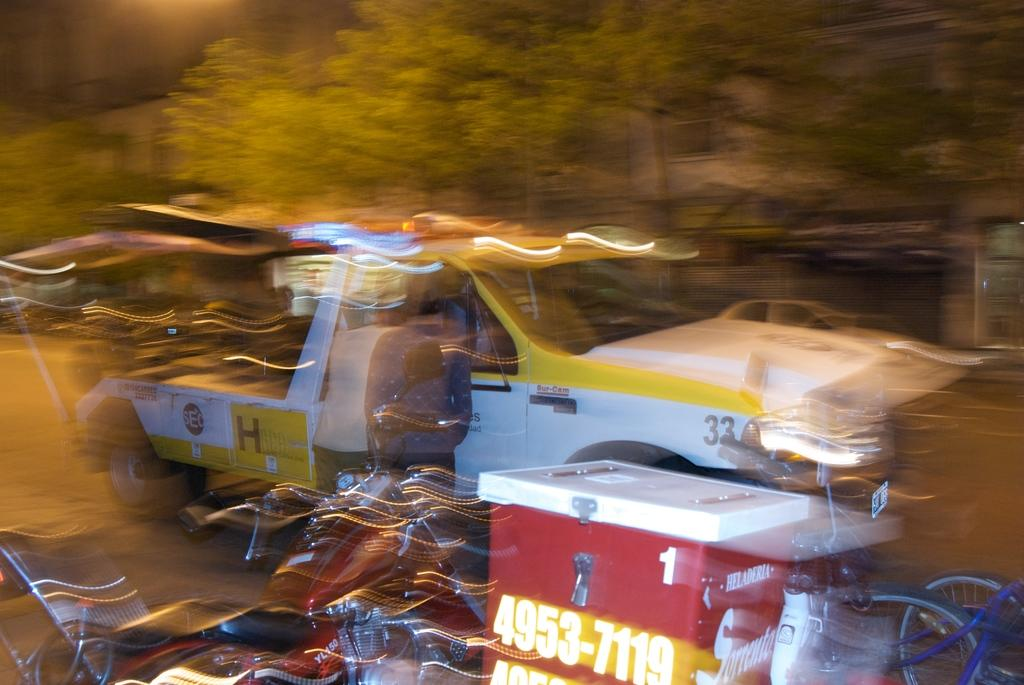What is happening on the road in the image? There are vehicles on the road in the image. What type of natural elements can be seen in the image? There are trees visible in the image. What type of man-made structures are present in the image? There are buildings in the image. What type of hammer can be seen being used on the land in the image? There is no hammer or land present in the image; it features vehicles on the road and trees and buildings in the background. 